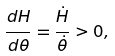Convert formula to latex. <formula><loc_0><loc_0><loc_500><loc_500>\frac { d H } { d \theta } = \frac { \dot { H } } { \dot { \theta } } > 0 ,</formula> 